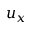<formula> <loc_0><loc_0><loc_500><loc_500>u _ { x }</formula> 